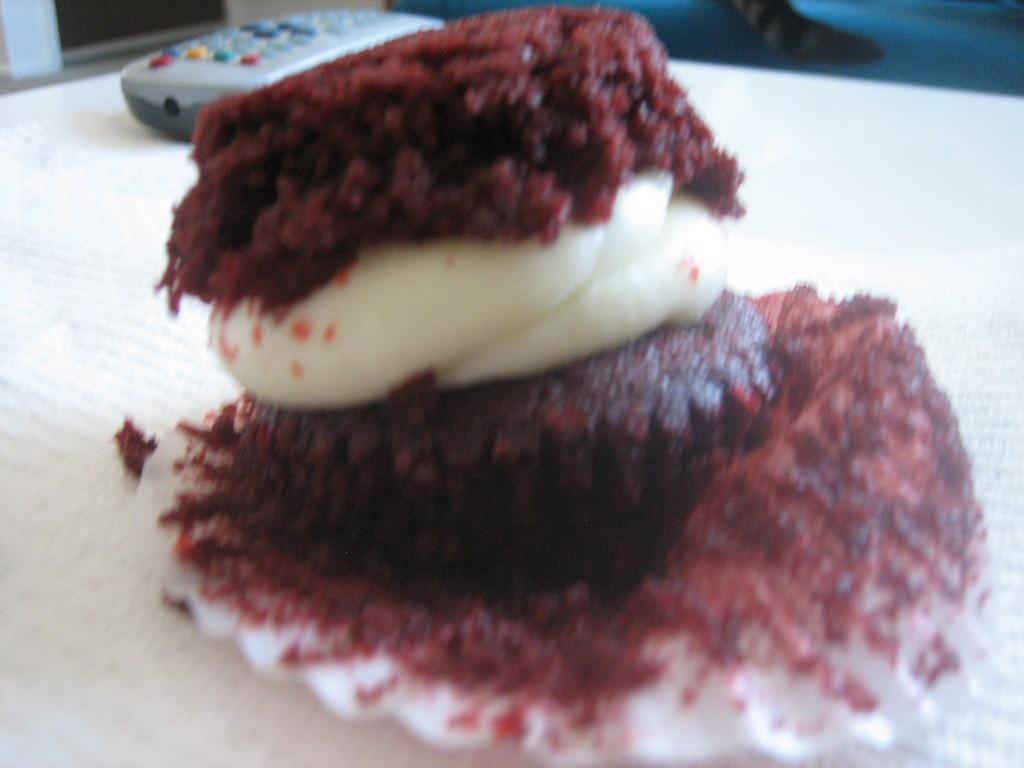What can be seen on the surface in the image? There is a food item on a surface in the image. What other object is visible in the image? There is a remote control in the image. Where is the receipt for the food item in the image? There is no receipt present in the image. Can you tell me how many times the person sneezed while preparing the food in the image? There is no indication of anyone sneezing in the image, as it only shows a food item and a remote control. 